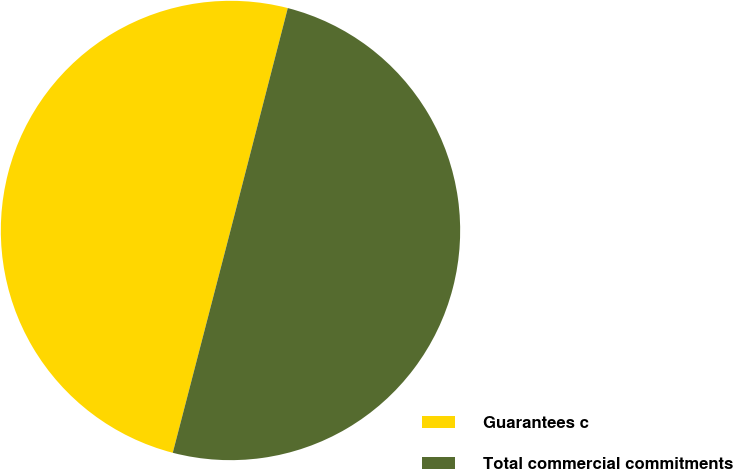<chart> <loc_0><loc_0><loc_500><loc_500><pie_chart><fcel>Guarantees c<fcel>Total commercial commitments<nl><fcel>49.97%<fcel>50.03%<nl></chart> 